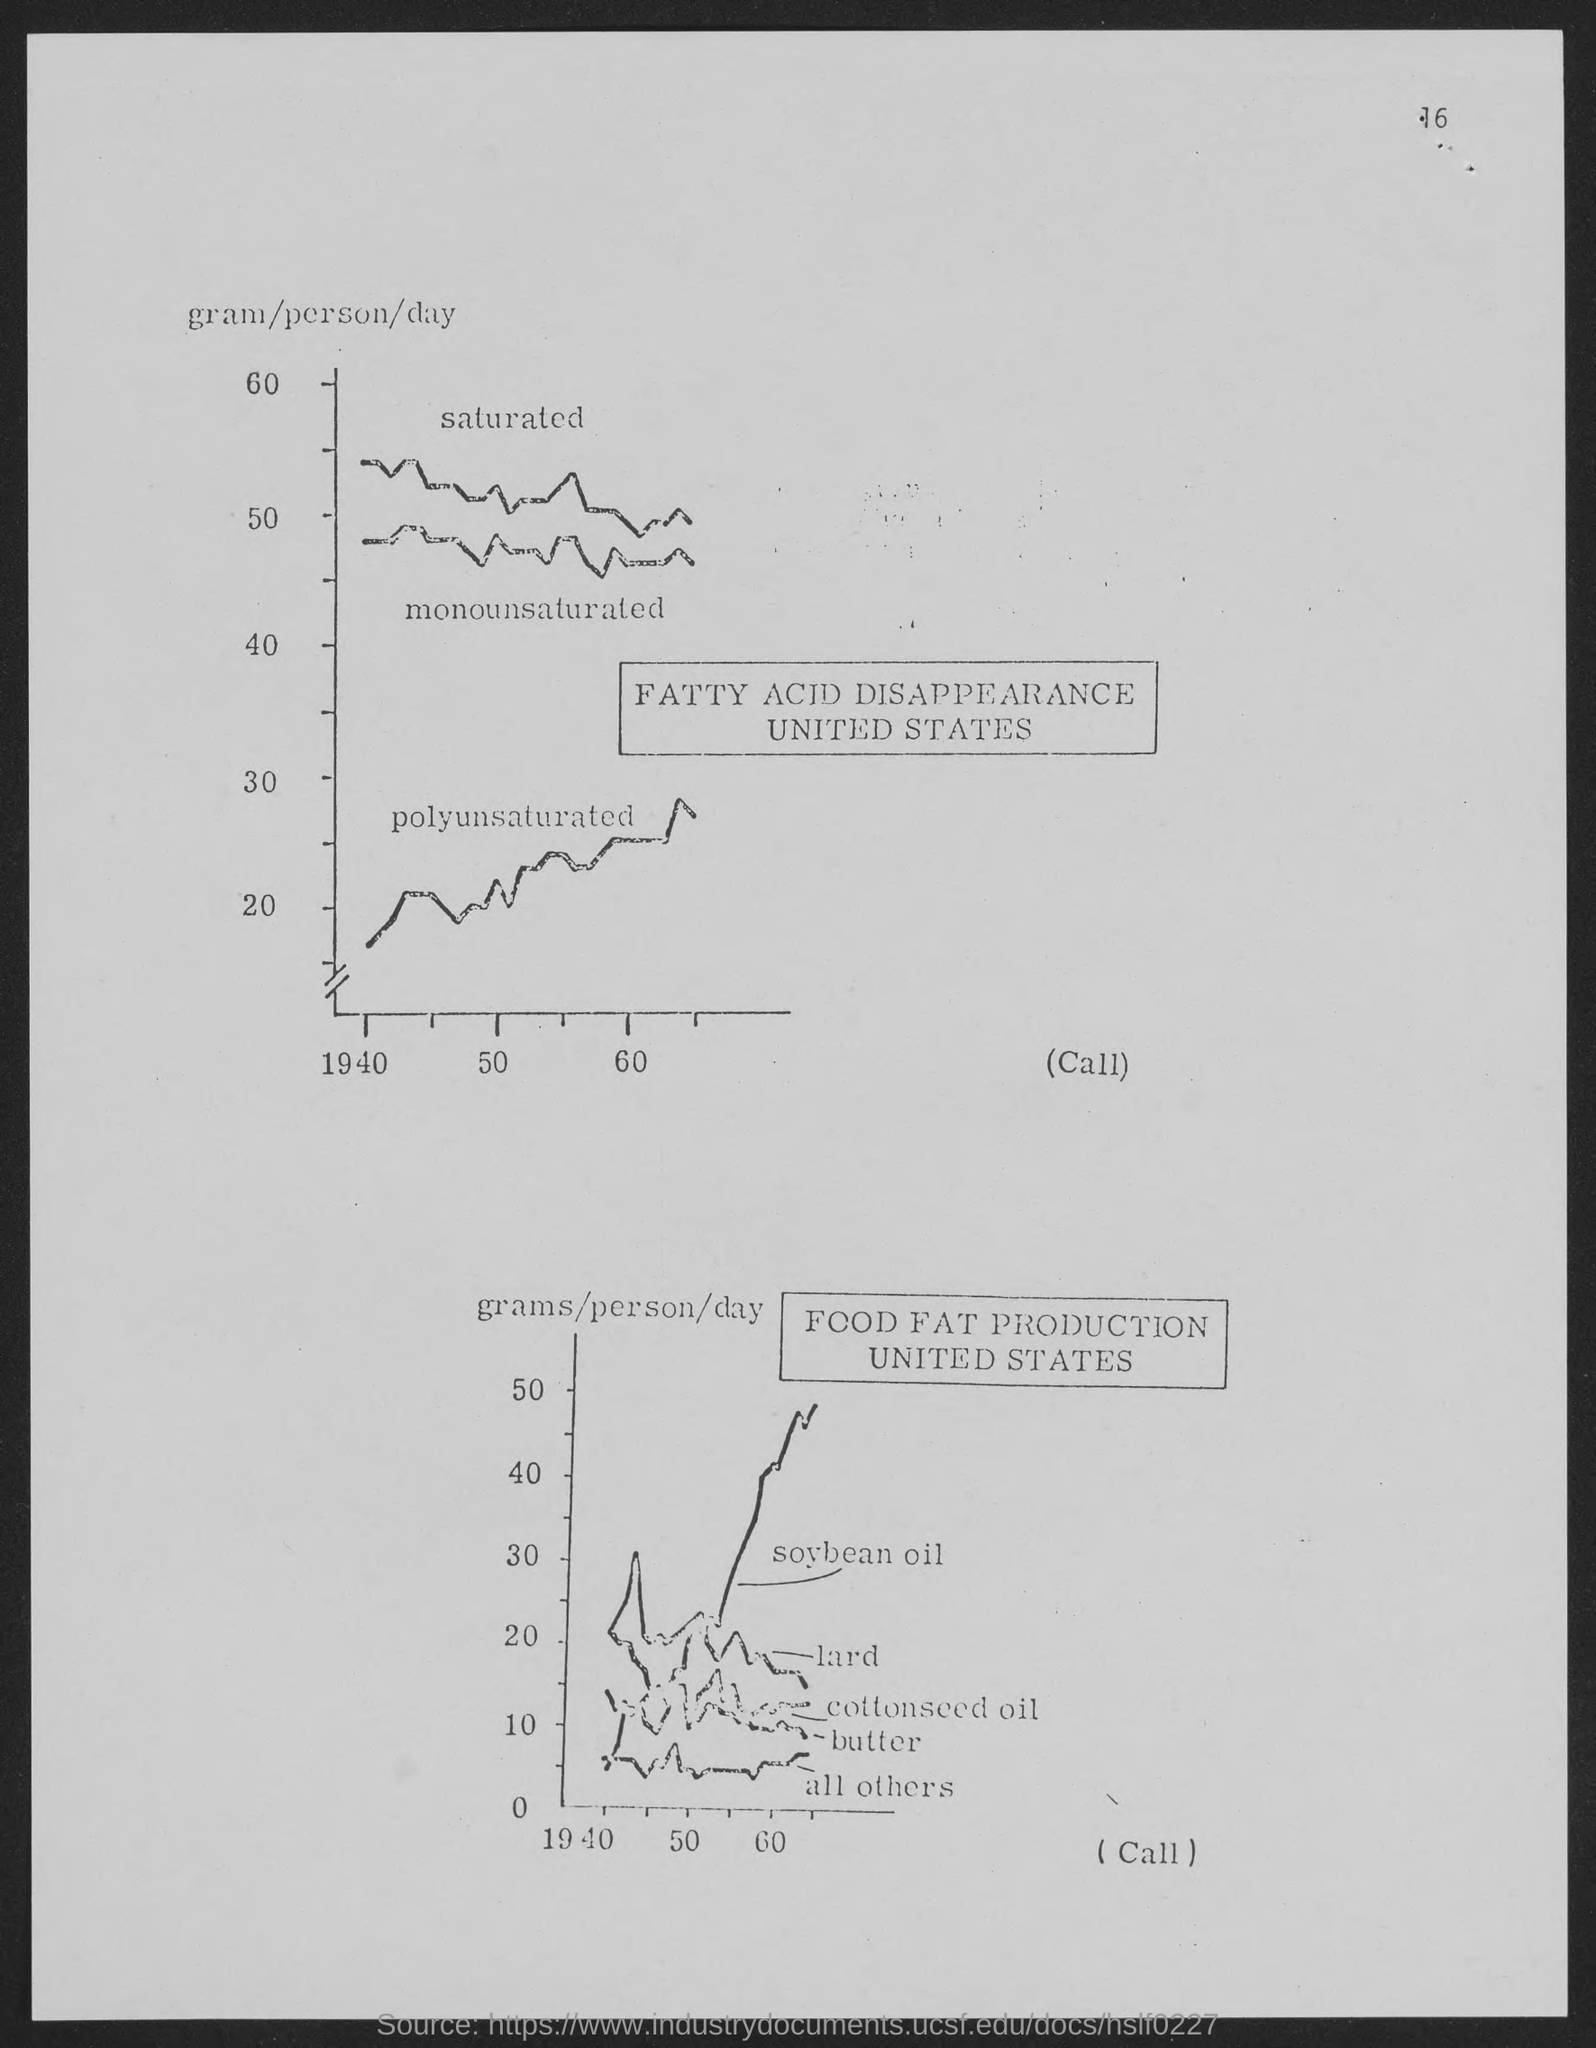What is the number at top of the page ?
Offer a very short reply. 16. 